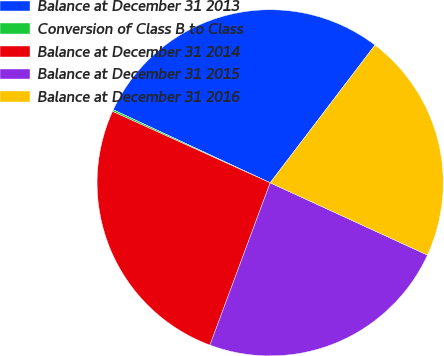<chart> <loc_0><loc_0><loc_500><loc_500><pie_chart><fcel>Balance at December 31 2013<fcel>Conversion of Class B to Class<fcel>Balance at December 31 2014<fcel>Balance at December 31 2015<fcel>Balance at December 31 2016<nl><fcel>28.42%<fcel>0.17%<fcel>26.11%<fcel>23.8%<fcel>21.5%<nl></chart> 